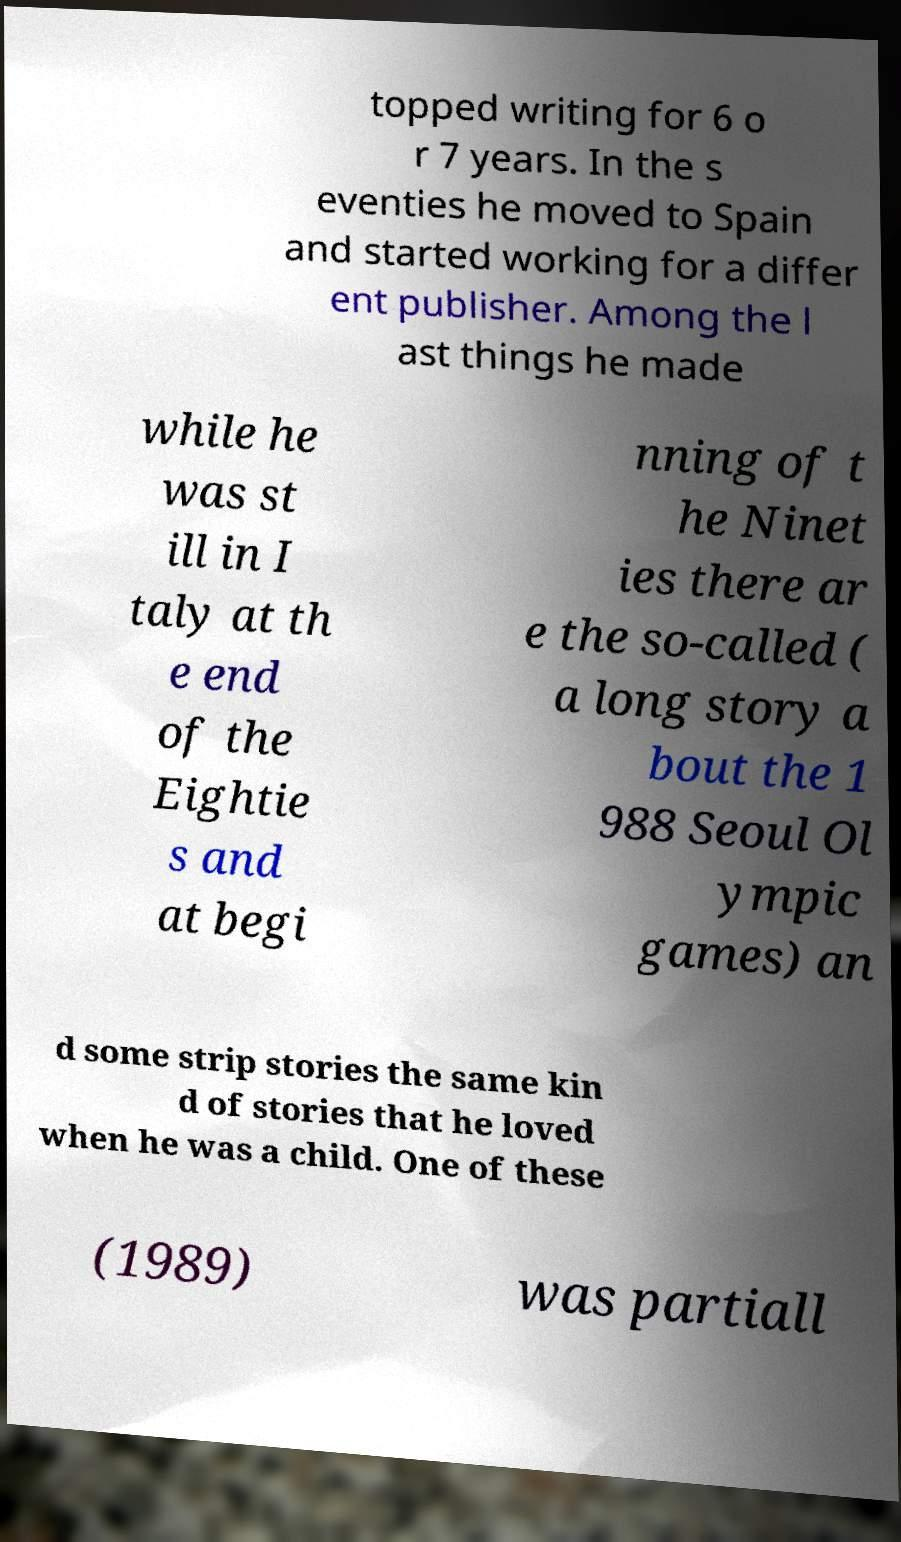For documentation purposes, I need the text within this image transcribed. Could you provide that? topped writing for 6 o r 7 years. In the s eventies he moved to Spain and started working for a differ ent publisher. Among the l ast things he made while he was st ill in I taly at th e end of the Eightie s and at begi nning of t he Ninet ies there ar e the so-called ( a long story a bout the 1 988 Seoul Ol ympic games) an d some strip stories the same kin d of stories that he loved when he was a child. One of these (1989) was partiall 